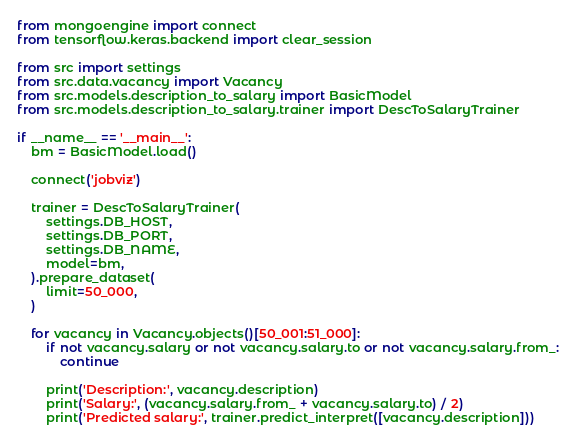Convert code to text. <code><loc_0><loc_0><loc_500><loc_500><_Python_>from mongoengine import connect
from tensorflow.keras.backend import clear_session

from src import settings
from src.data.vacancy import Vacancy
from src.models.description_to_salary import BasicModel
from src.models.description_to_salary.trainer import DescToSalaryTrainer

if __name__ == '__main__':
    bm = BasicModel.load()

    connect('jobviz')

    trainer = DescToSalaryTrainer(
        settings.DB_HOST,
        settings.DB_PORT,
        settings.DB_NAME,
        model=bm,
    ).prepare_dataset(
        limit=50_000,
    )

    for vacancy in Vacancy.objects()[50_001:51_000]:
        if not vacancy.salary or not vacancy.salary.to or not vacancy.salary.from_:
            continue

        print('Description:', vacancy.description)
        print('Salary:', (vacancy.salary.from_ + vacancy.salary.to) / 2)
        print('Predicted salary:', trainer.predict_interpret([vacancy.description]))
</code> 